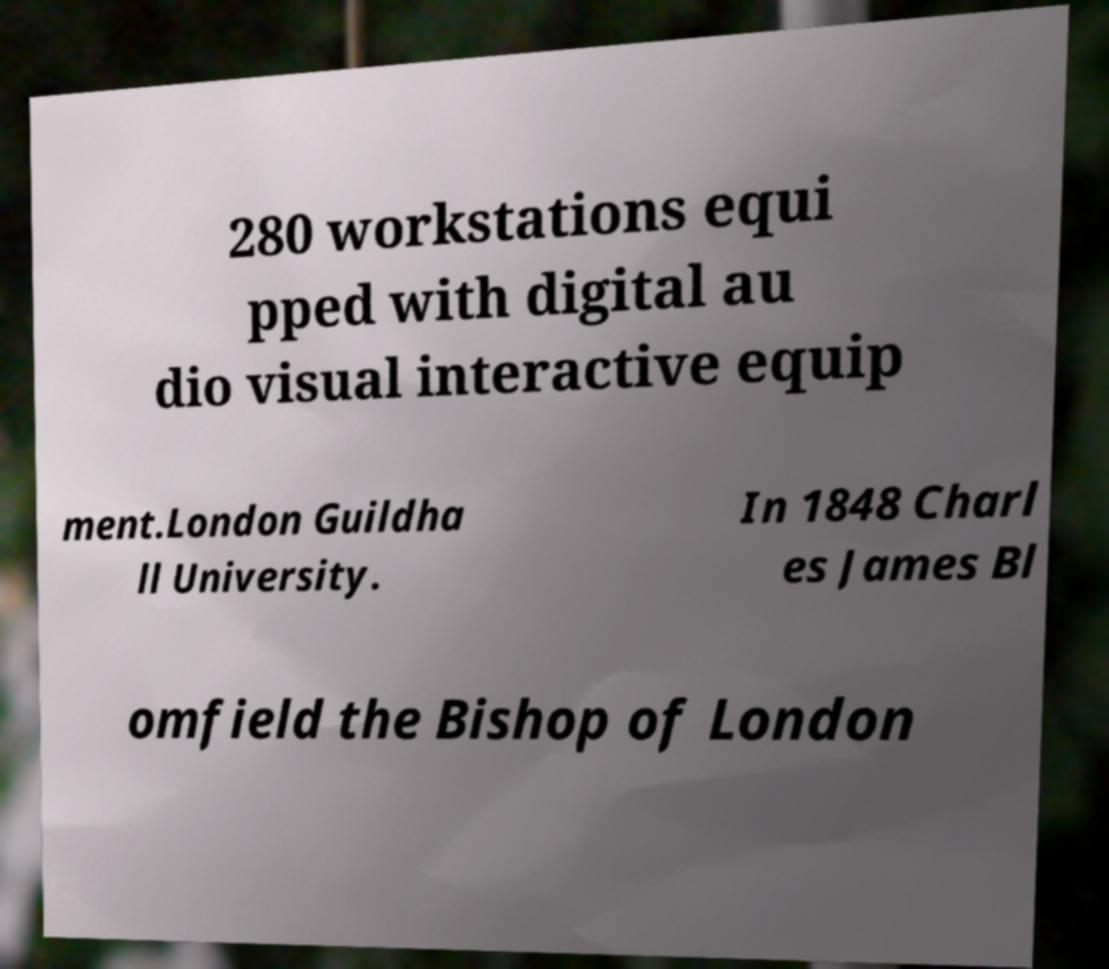Could you assist in decoding the text presented in this image and type it out clearly? 280 workstations equi pped with digital au dio visual interactive equip ment.London Guildha ll University. In 1848 Charl es James Bl omfield the Bishop of London 